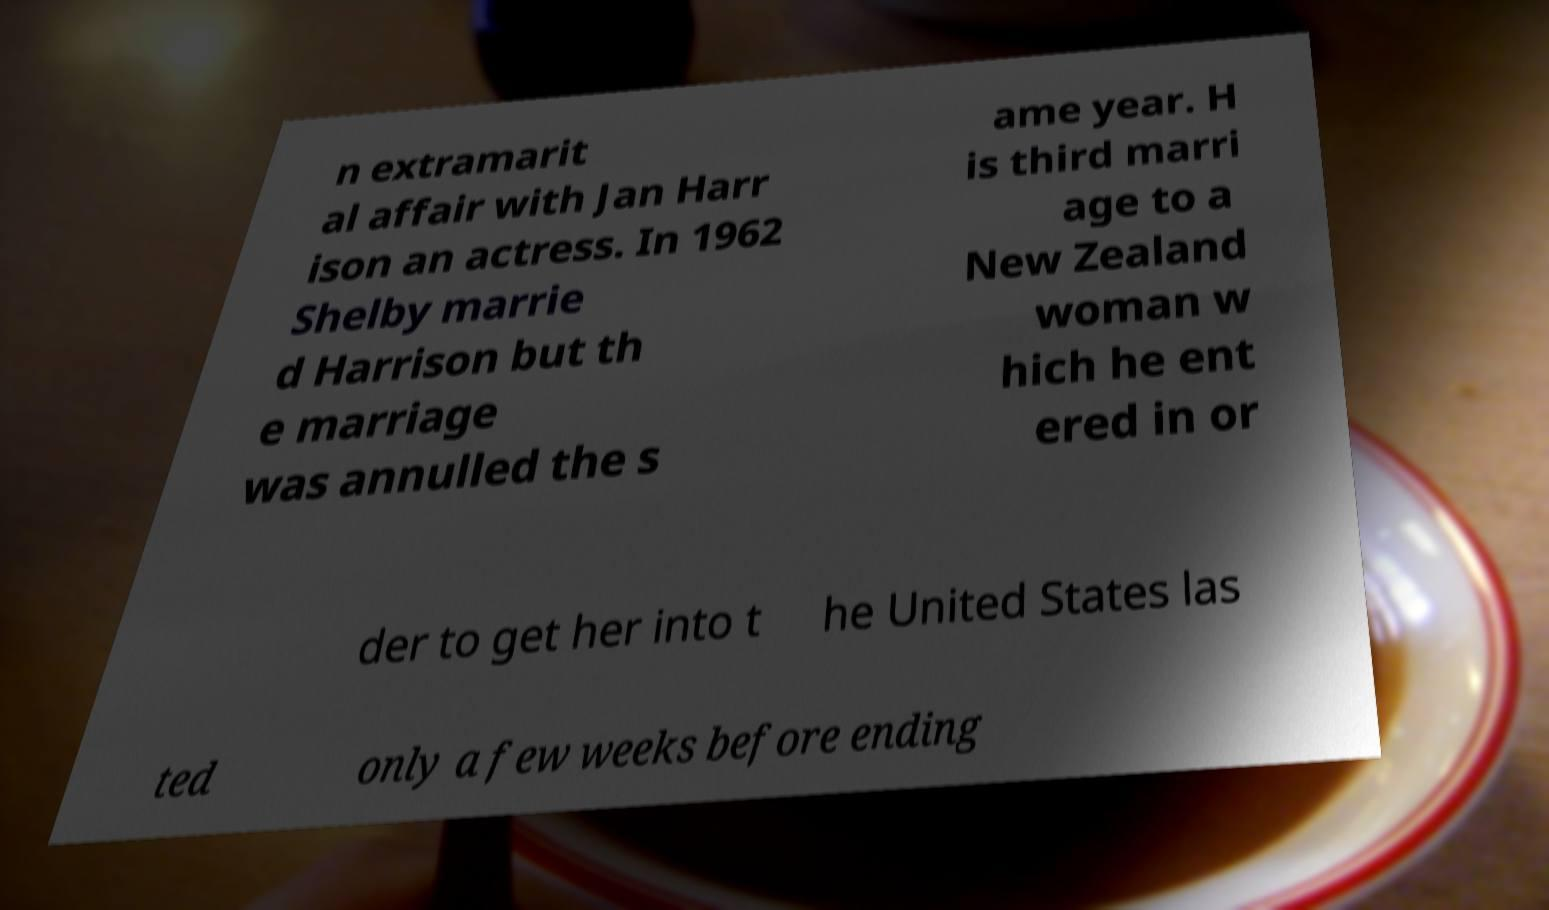What messages or text are displayed in this image? I need them in a readable, typed format. n extramarit al affair with Jan Harr ison an actress. In 1962 Shelby marrie d Harrison but th e marriage was annulled the s ame year. H is third marri age to a New Zealand woman w hich he ent ered in or der to get her into t he United States las ted only a few weeks before ending 